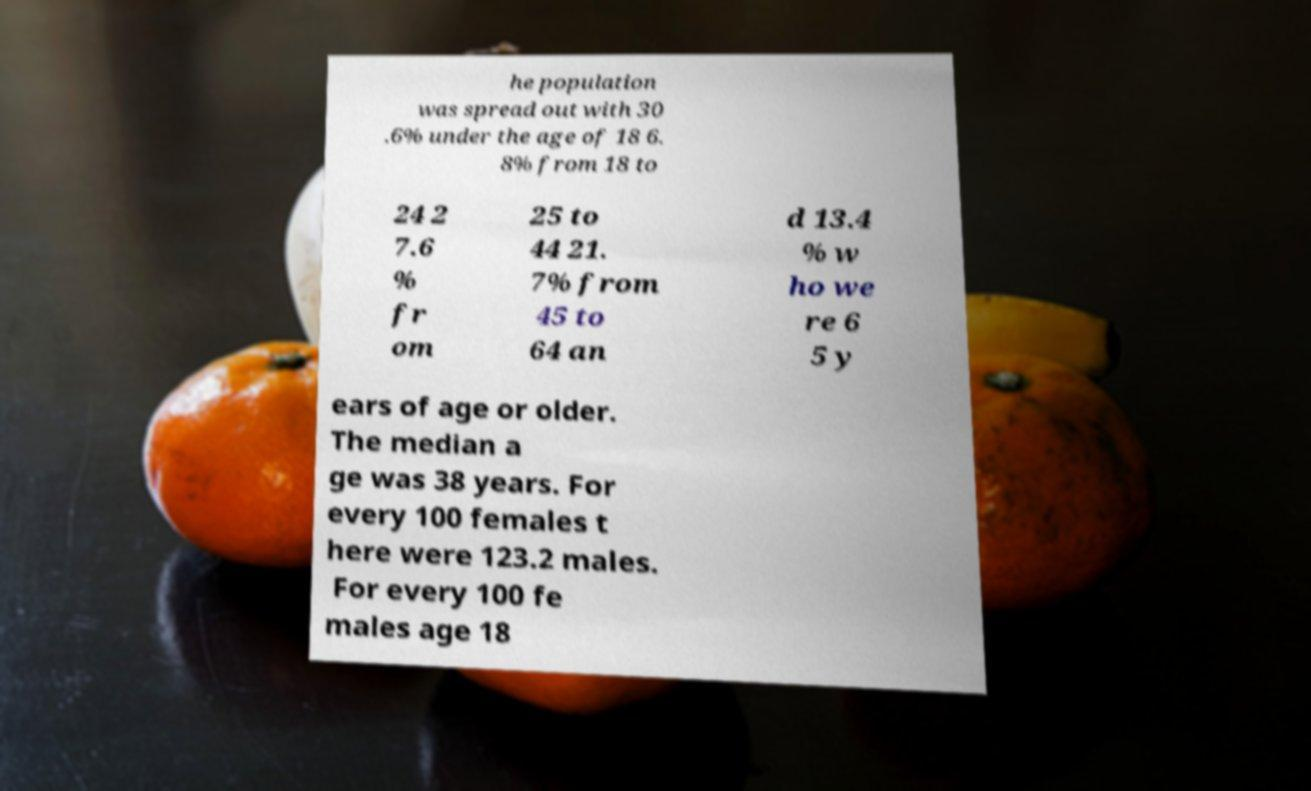Could you assist in decoding the text presented in this image and type it out clearly? he population was spread out with 30 .6% under the age of 18 6. 8% from 18 to 24 2 7.6 % fr om 25 to 44 21. 7% from 45 to 64 an d 13.4 % w ho we re 6 5 y ears of age or older. The median a ge was 38 years. For every 100 females t here were 123.2 males. For every 100 fe males age 18 